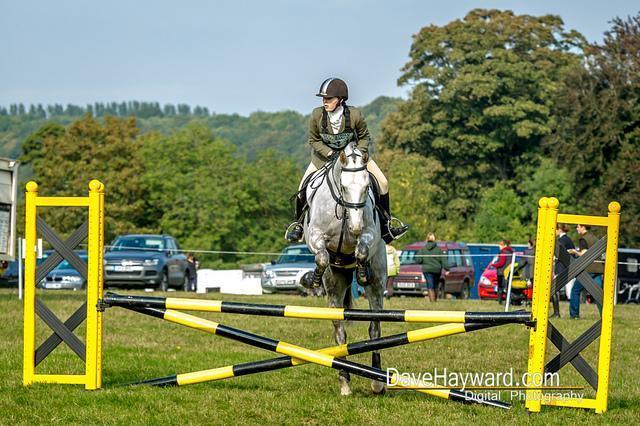How many cars are in the picture?
Give a very brief answer. 2. 